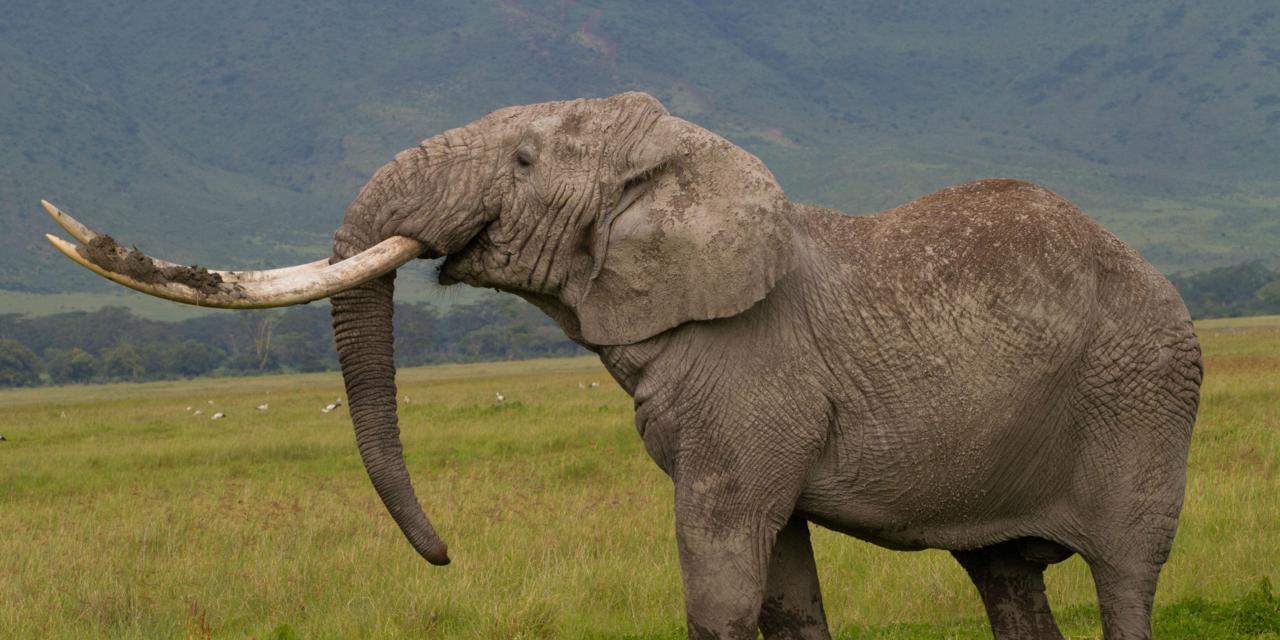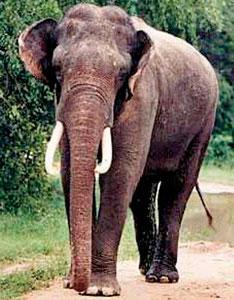The first image is the image on the left, the second image is the image on the right. For the images displayed, is the sentence "The elephant in the right image is walking towards the right." factually correct? Answer yes or no. No. The first image is the image on the left, the second image is the image on the right. Assess this claim about the two images: "The left image includes an elephant with tusks, but the right image contains only a tuskless elephant.". Correct or not? Answer yes or no. No. 